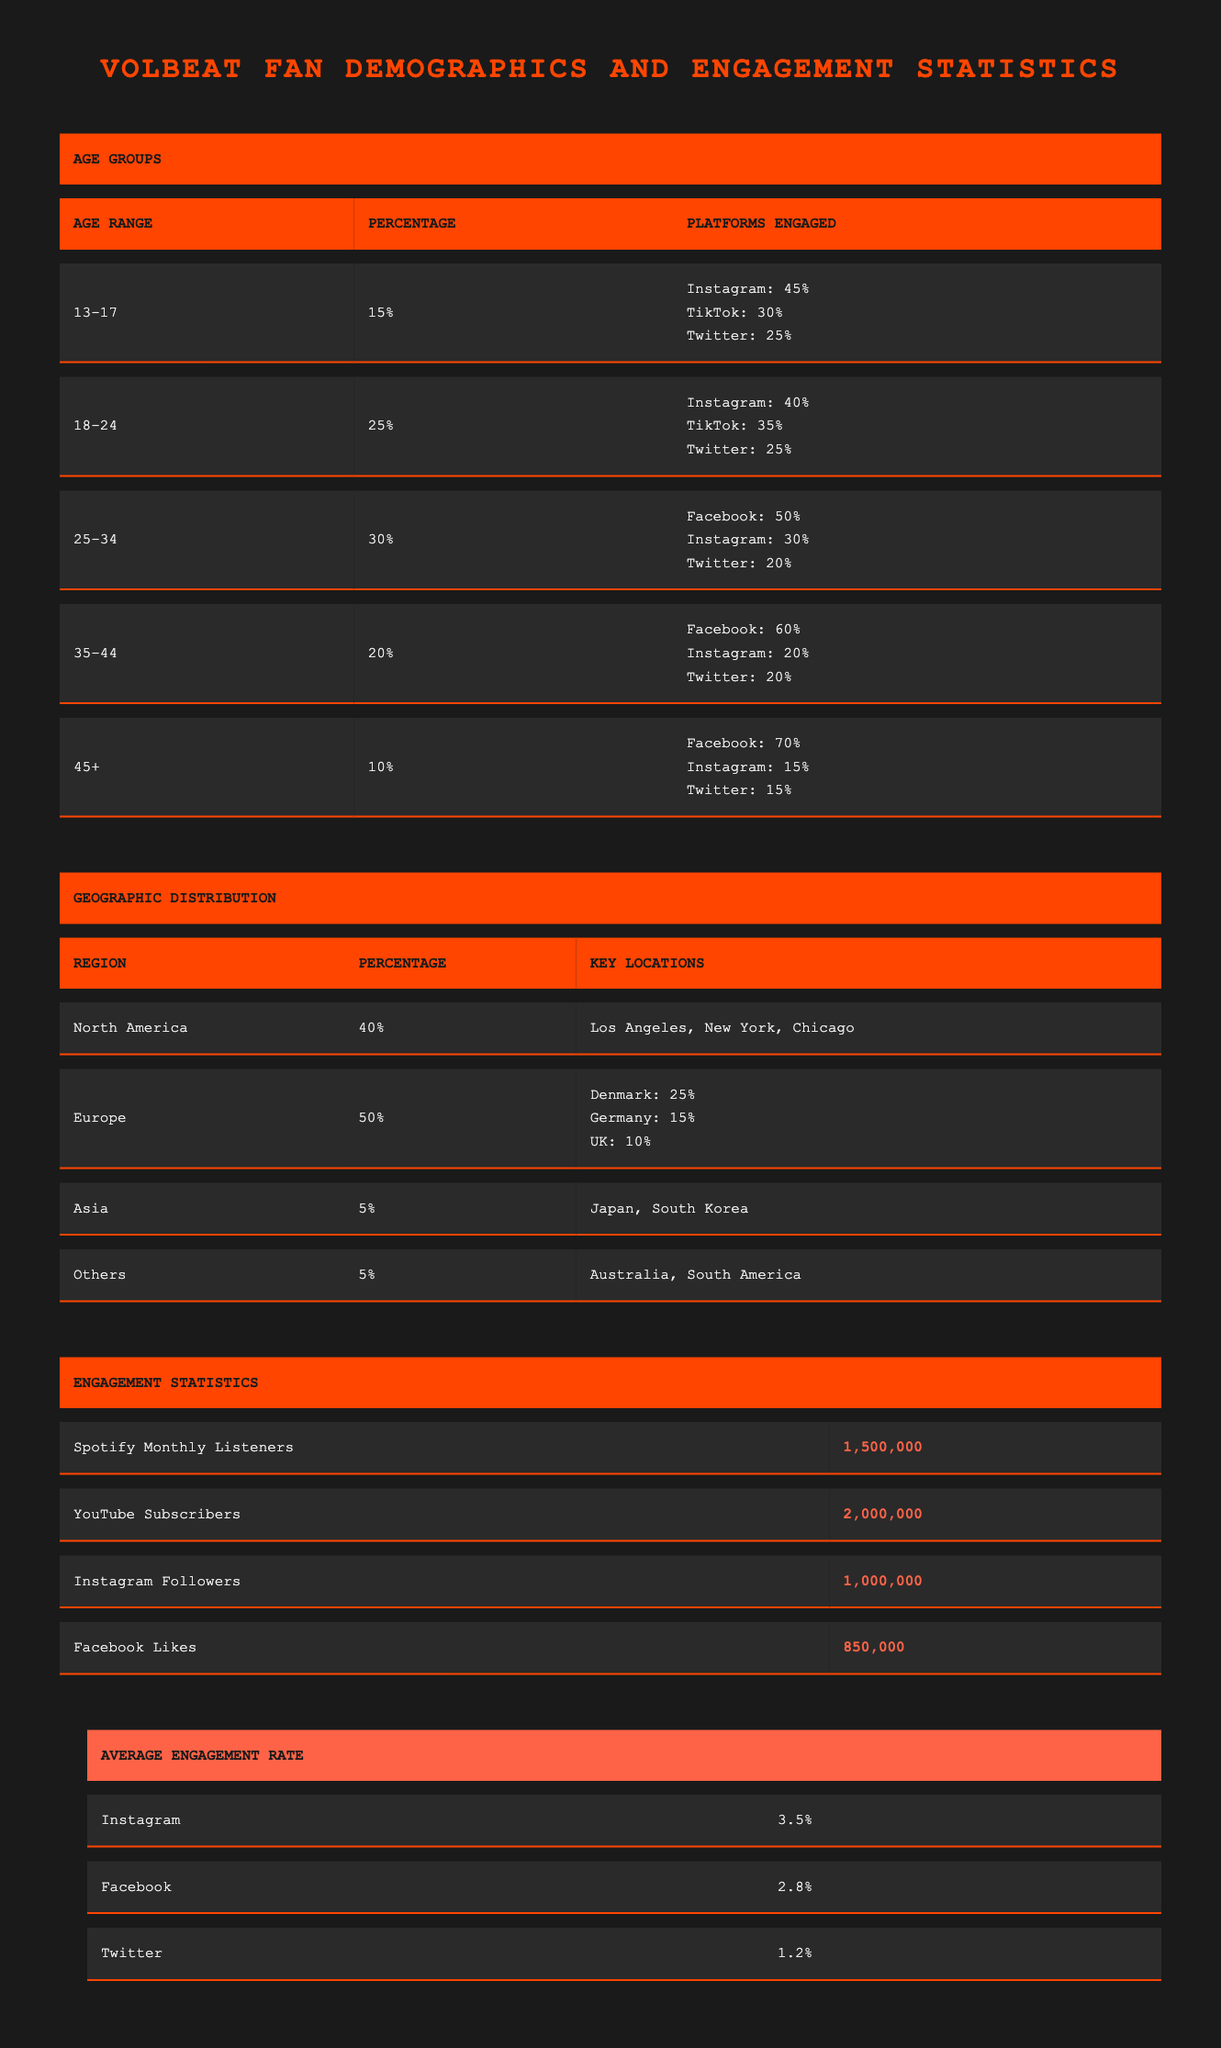What percentage of Volbeat fans are in the age group 25-34? From the Age Groups table, the row corresponding to the age range 25-34 shows a Percentage of 30%.
Answer: 30% Which social media platform has the highest engagement percentage among the 13-17 age group? In the Platforms Engaged section for the 13-17 age group, Instagram has 45%, TikTok has 30%, and Twitter has 25%. Thus, Instagram has the highest engagement percentage.
Answer: Instagram What is the total engagement percentage across all platforms for the 18-24 age group? For the 18-24 age group, adding the engagement percentages: Instagram 40% + TikTok 35% + Twitter 25% gives a total of 100%.
Answer: 100% In which region do Volbeat fans make up the largest percentage? According to the Geographic Distribution table, Europe has the highest percentage at 50%, indicating that more Volbeat fans are concentrated there compared to other regions.
Answer: Europe Is the average engagement rate for Facebook higher than that for Instagram? The Average Engagement Rate shows 2.8% for Facebook and 3.5% for Instagram. Since 2.8% is less than 3.5%, this statement is false.
Answer: No How many Spotify Monthly Listeners does Volbeat have if the YouTube Subscribers are not considered? The Engagement Statistics table specifies that Volbeat has 1,500,000 Spotify Monthly Listeners. The number for YouTube Subscribers is irrelevant to this question.
Answer: 1,500,000 What is the average engagement rate across Instagram and Twitter? The average engagement rates for Instagram and Twitter are 3.5% and 1.2%, respectively. The total is 3.5% + 1.2% = 4.7%. Dividing by 2 for the average results in 4.7% / 2 = 2.35%.
Answer: 2.35% In North America, what percentage of Volbeat fans are located compared to Europe? North America has 40% and Europe has 50% of Volbeat fans. Thus, Europe has a higher percentage by 10%.
Answer: Europe Which age group has the lowest percentage of Volbeat fans? Reviewing the Age Groups table, the 45+ age group shows a percentage of 10%, which is the lowest compared to the other age groups.
Answer: 45+ 